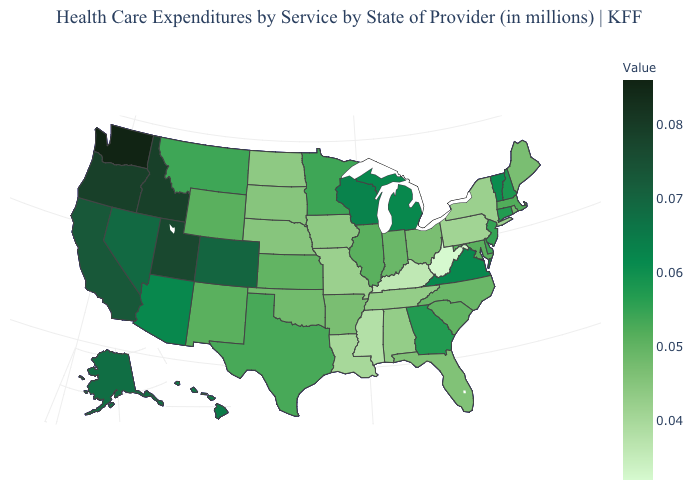Among the states that border Wyoming , does South Dakota have the lowest value?
Answer briefly. Yes. Which states have the highest value in the USA?
Short answer required. Washington. Among the states that border Virginia , which have the lowest value?
Give a very brief answer. West Virginia. 